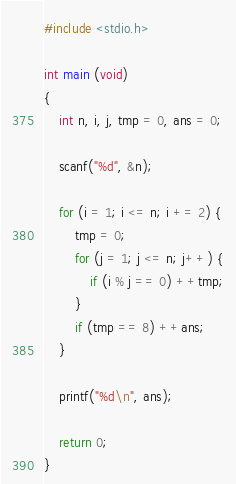Convert code to text. <code><loc_0><loc_0><loc_500><loc_500><_C_>#include <stdio.h>

int main (void)
{
    int n, i, j, tmp = 0, ans = 0;

    scanf("%d", &n);

    for (i = 1; i <= n; i += 2) {
        tmp = 0;
        for (j = 1; j <= n; j++) {
            if (i % j == 0) ++tmp;
        }
        if (tmp == 8) ++ans;
    }

    printf("%d\n", ans);

    return 0;
}
</code> 